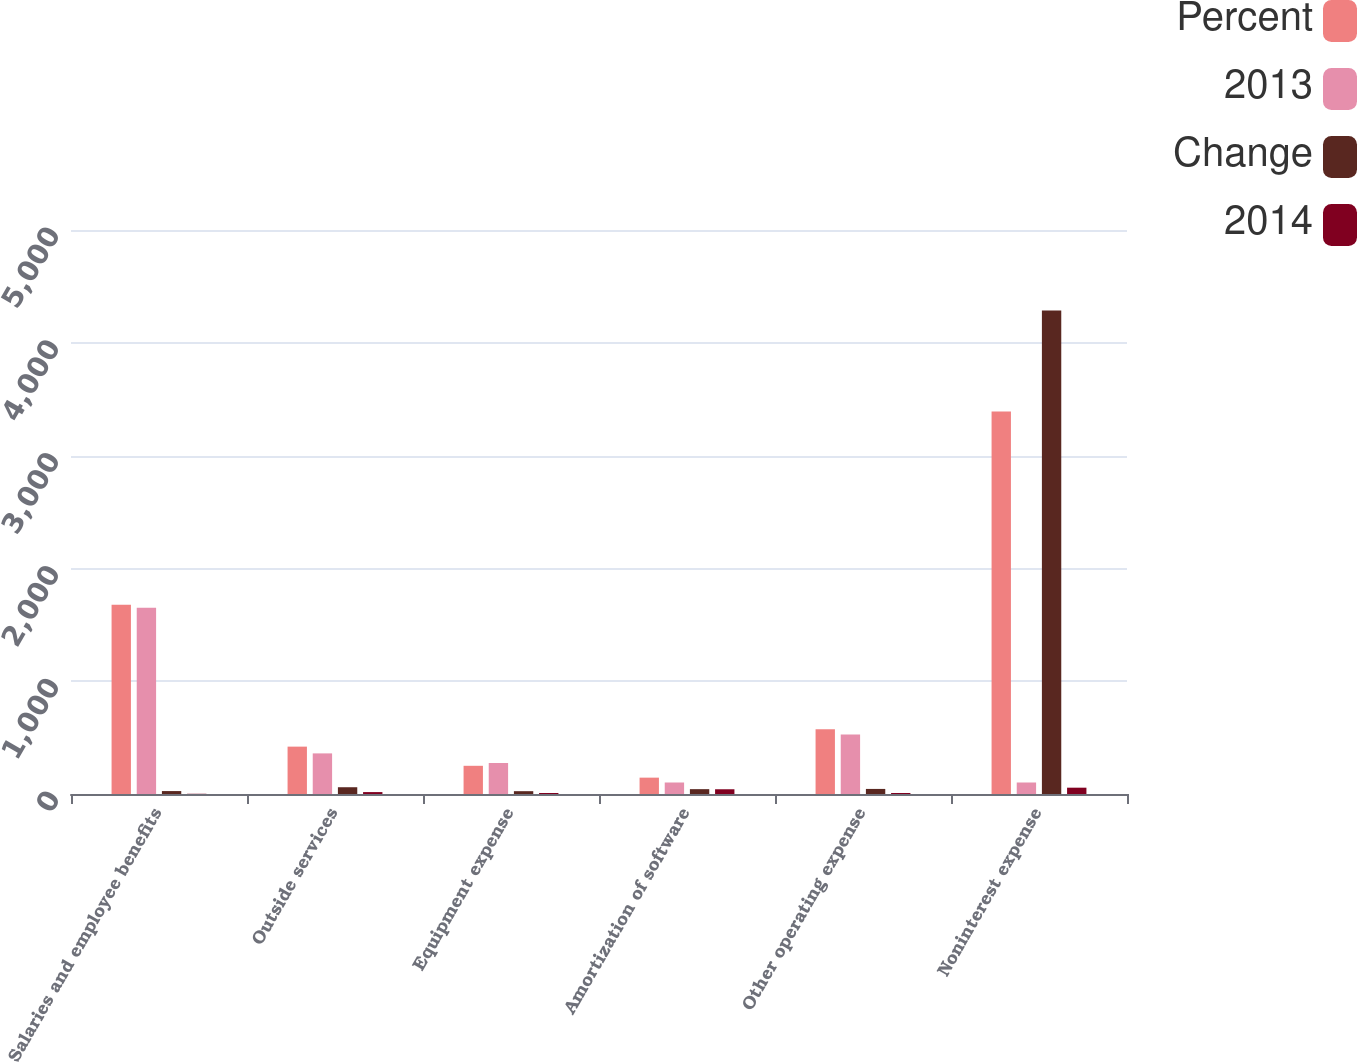Convert chart. <chart><loc_0><loc_0><loc_500><loc_500><stacked_bar_chart><ecel><fcel>Salaries and employee benefits<fcel>Outside services<fcel>Equipment expense<fcel>Amortization of software<fcel>Other operating expense<fcel>Noninterest expense<nl><fcel>Percent<fcel>1678<fcel>420<fcel>250<fcel>145<fcel>573<fcel>3392<nl><fcel>2013<fcel>1652<fcel>360<fcel>275<fcel>102<fcel>528<fcel>102<nl><fcel>Change<fcel>26<fcel>60<fcel>25<fcel>43<fcel>45<fcel>4287<nl><fcel>2014<fcel>2<fcel>17<fcel>9<fcel>42<fcel>9<fcel>56<nl></chart> 